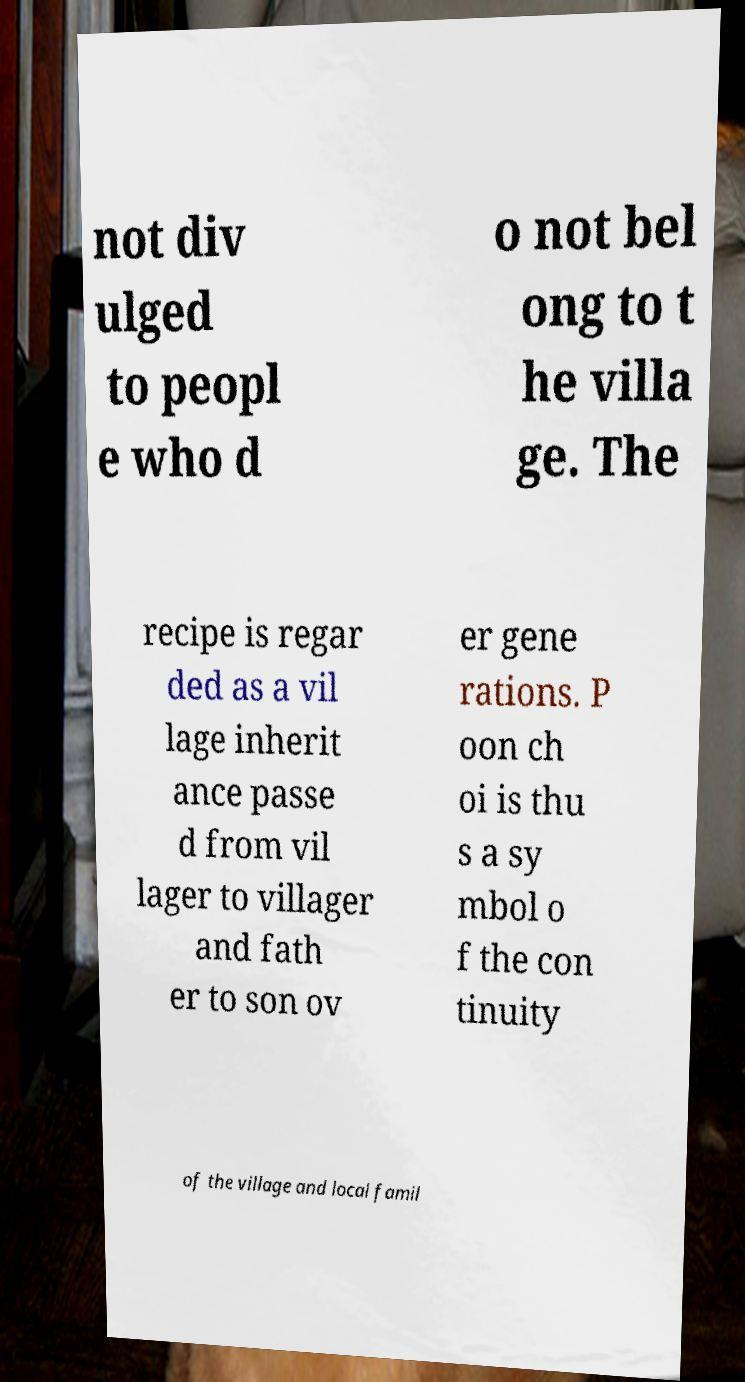For documentation purposes, I need the text within this image transcribed. Could you provide that? not div ulged to peopl e who d o not bel ong to t he villa ge. The recipe is regar ded as a vil lage inherit ance passe d from vil lager to villager and fath er to son ov er gene rations. P oon ch oi is thu s a sy mbol o f the con tinuity of the village and local famil 